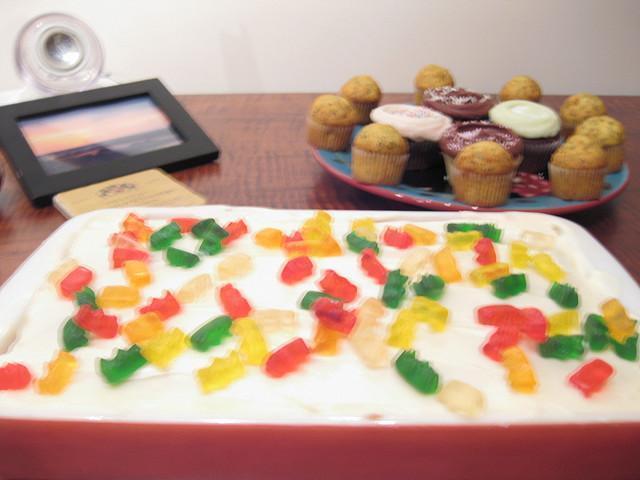How many mini muffins are on the plate?
Give a very brief answer. 9. 